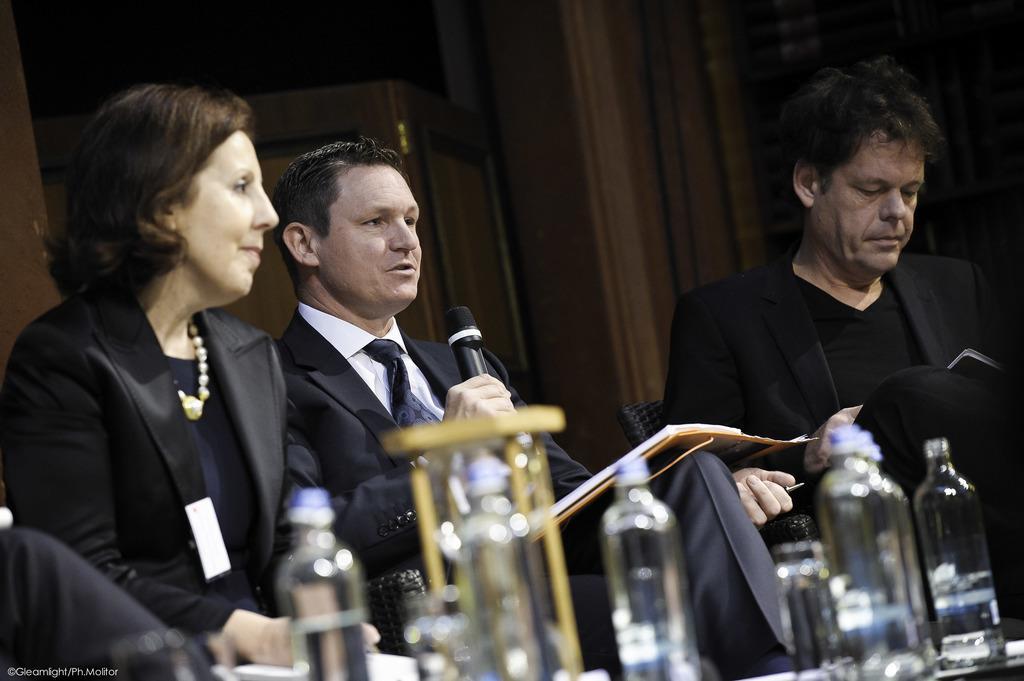Describe this image in one or two sentences. There are three people sitting. The person in the middle is holding mike and talking. These are the bottles placed on the table. 